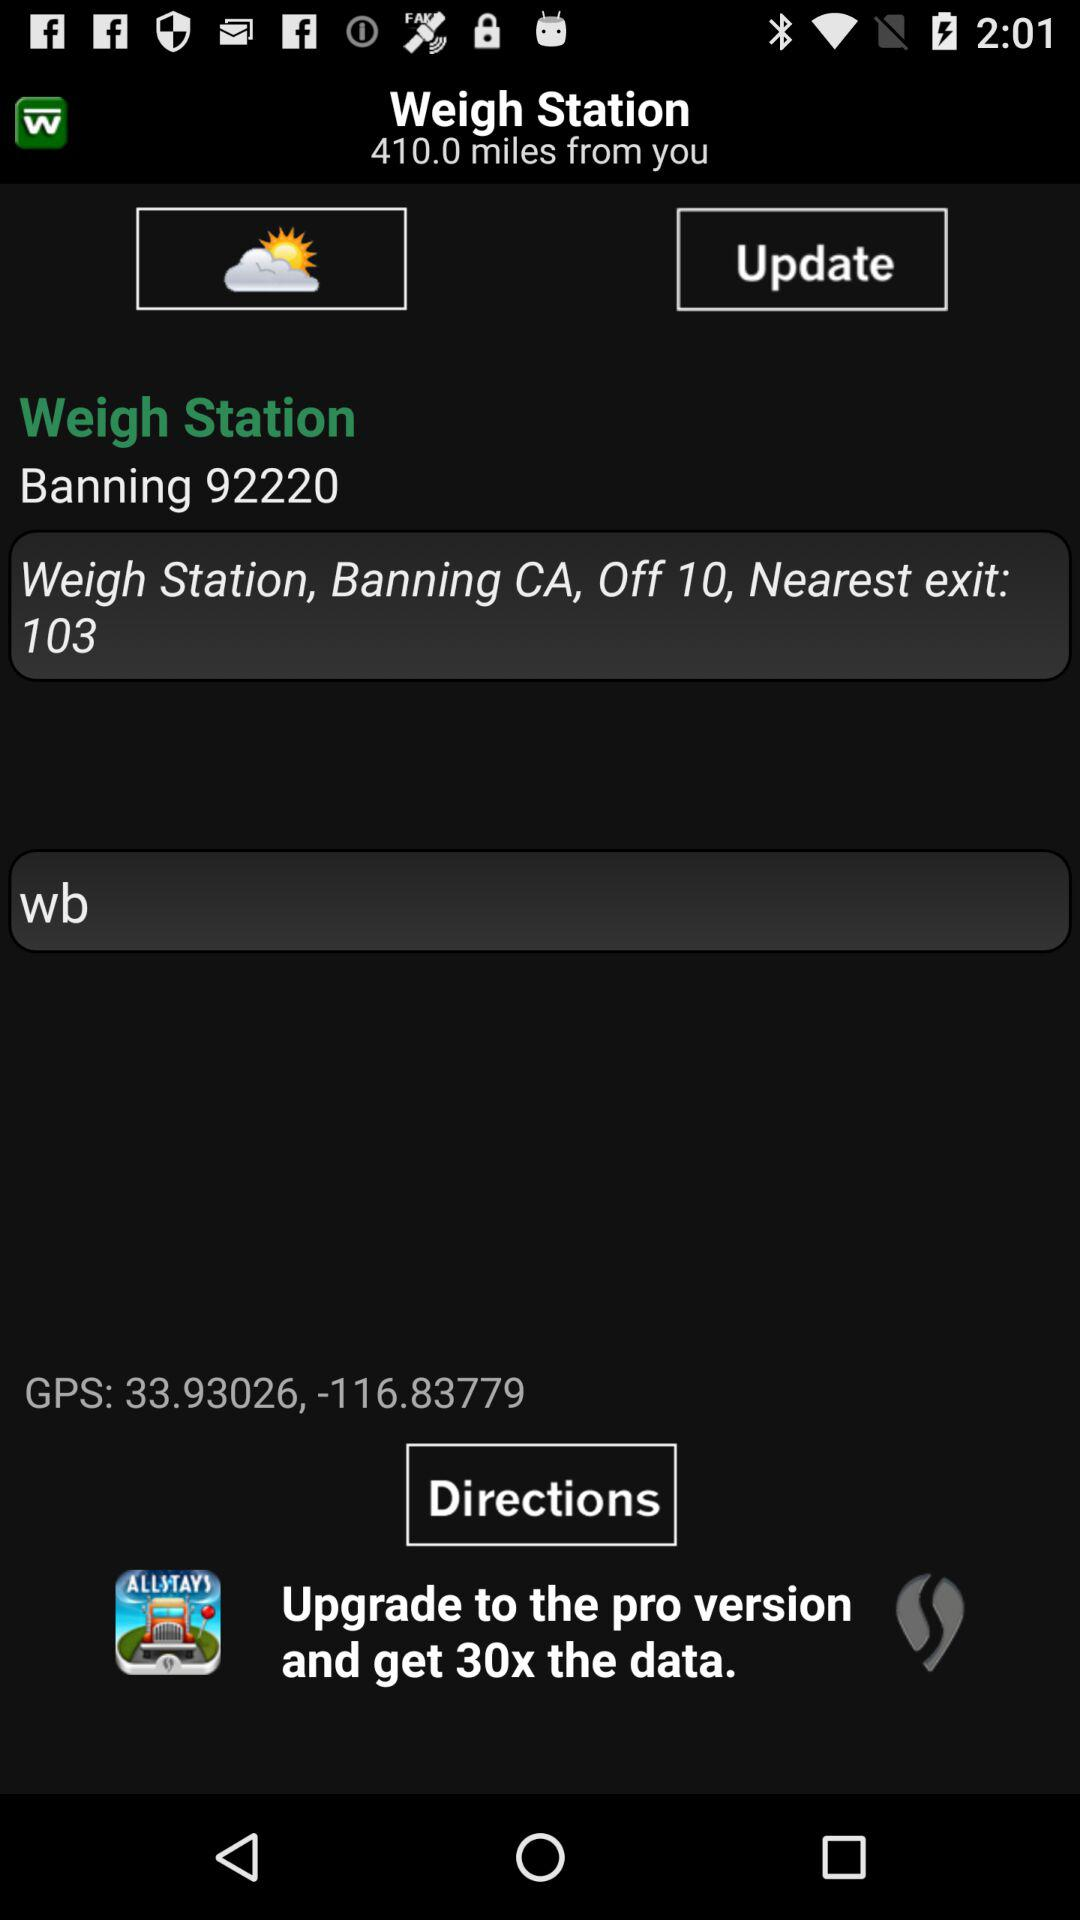What is the latitude of the weight station? The latitude of the weight station is 33.93026, -116.83779. 